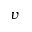<formula> <loc_0><loc_0><loc_500><loc_500>v</formula> 